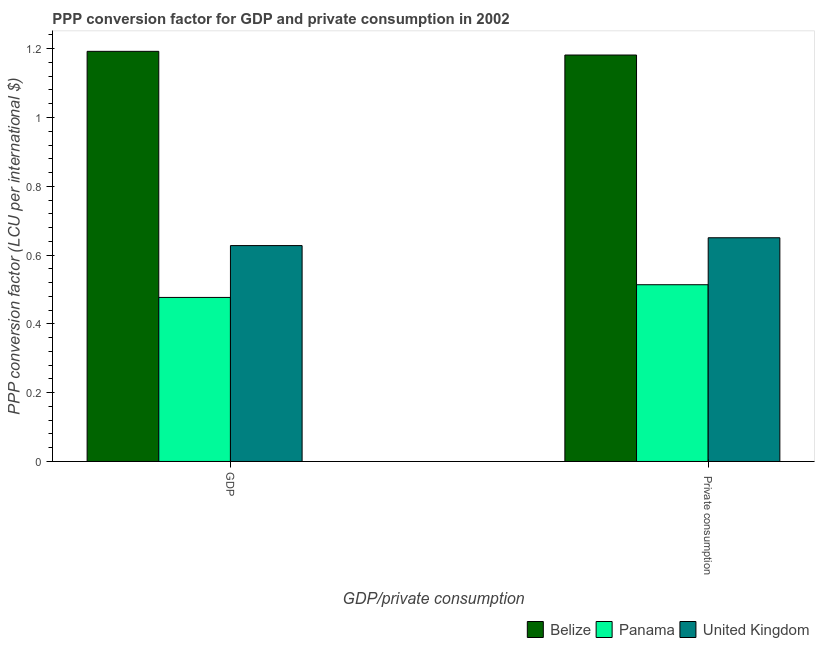How many groups of bars are there?
Your answer should be compact. 2. How many bars are there on the 1st tick from the left?
Your response must be concise. 3. What is the label of the 2nd group of bars from the left?
Make the answer very short.  Private consumption. What is the ppp conversion factor for gdp in United Kingdom?
Provide a succinct answer. 0.63. Across all countries, what is the maximum ppp conversion factor for private consumption?
Your response must be concise. 1.18. Across all countries, what is the minimum ppp conversion factor for private consumption?
Offer a terse response. 0.51. In which country was the ppp conversion factor for gdp maximum?
Keep it short and to the point. Belize. In which country was the ppp conversion factor for private consumption minimum?
Your answer should be very brief. Panama. What is the total ppp conversion factor for gdp in the graph?
Make the answer very short. 2.3. What is the difference between the ppp conversion factor for gdp in United Kingdom and that in Belize?
Ensure brevity in your answer.  -0.56. What is the difference between the ppp conversion factor for private consumption in United Kingdom and the ppp conversion factor for gdp in Panama?
Provide a succinct answer. 0.17. What is the average ppp conversion factor for gdp per country?
Your response must be concise. 0.77. What is the difference between the ppp conversion factor for gdp and ppp conversion factor for private consumption in United Kingdom?
Offer a very short reply. -0.02. What is the ratio of the ppp conversion factor for gdp in United Kingdom to that in Panama?
Give a very brief answer. 1.32. What does the 1st bar from the left in GDP represents?
Provide a short and direct response. Belize. What does the 3rd bar from the right in  Private consumption represents?
Your response must be concise. Belize. How many bars are there?
Offer a very short reply. 6. How many countries are there in the graph?
Provide a succinct answer. 3. What is the difference between two consecutive major ticks on the Y-axis?
Provide a short and direct response. 0.2. Are the values on the major ticks of Y-axis written in scientific E-notation?
Offer a very short reply. No. How many legend labels are there?
Provide a short and direct response. 3. How are the legend labels stacked?
Give a very brief answer. Horizontal. What is the title of the graph?
Offer a terse response. PPP conversion factor for GDP and private consumption in 2002. Does "Zambia" appear as one of the legend labels in the graph?
Your response must be concise. No. What is the label or title of the X-axis?
Your answer should be very brief. GDP/private consumption. What is the label or title of the Y-axis?
Keep it short and to the point. PPP conversion factor (LCU per international $). What is the PPP conversion factor (LCU per international $) of Belize in GDP?
Provide a short and direct response. 1.19. What is the PPP conversion factor (LCU per international $) of Panama in GDP?
Your answer should be very brief. 0.48. What is the PPP conversion factor (LCU per international $) of United Kingdom in GDP?
Your response must be concise. 0.63. What is the PPP conversion factor (LCU per international $) in Belize in  Private consumption?
Offer a terse response. 1.18. What is the PPP conversion factor (LCU per international $) in Panama in  Private consumption?
Provide a short and direct response. 0.51. What is the PPP conversion factor (LCU per international $) in United Kingdom in  Private consumption?
Provide a short and direct response. 0.65. Across all GDP/private consumption, what is the maximum PPP conversion factor (LCU per international $) of Belize?
Your response must be concise. 1.19. Across all GDP/private consumption, what is the maximum PPP conversion factor (LCU per international $) of Panama?
Your answer should be compact. 0.51. Across all GDP/private consumption, what is the maximum PPP conversion factor (LCU per international $) in United Kingdom?
Offer a very short reply. 0.65. Across all GDP/private consumption, what is the minimum PPP conversion factor (LCU per international $) in Belize?
Offer a very short reply. 1.18. Across all GDP/private consumption, what is the minimum PPP conversion factor (LCU per international $) of Panama?
Give a very brief answer. 0.48. Across all GDP/private consumption, what is the minimum PPP conversion factor (LCU per international $) in United Kingdom?
Keep it short and to the point. 0.63. What is the total PPP conversion factor (LCU per international $) in Belize in the graph?
Ensure brevity in your answer.  2.37. What is the total PPP conversion factor (LCU per international $) of Panama in the graph?
Your answer should be compact. 0.99. What is the total PPP conversion factor (LCU per international $) in United Kingdom in the graph?
Your answer should be very brief. 1.28. What is the difference between the PPP conversion factor (LCU per international $) of Belize in GDP and that in  Private consumption?
Give a very brief answer. 0.01. What is the difference between the PPP conversion factor (LCU per international $) of Panama in GDP and that in  Private consumption?
Your answer should be compact. -0.04. What is the difference between the PPP conversion factor (LCU per international $) of United Kingdom in GDP and that in  Private consumption?
Your response must be concise. -0.02. What is the difference between the PPP conversion factor (LCU per international $) in Belize in GDP and the PPP conversion factor (LCU per international $) in Panama in  Private consumption?
Provide a succinct answer. 0.68. What is the difference between the PPP conversion factor (LCU per international $) in Belize in GDP and the PPP conversion factor (LCU per international $) in United Kingdom in  Private consumption?
Offer a very short reply. 0.54. What is the difference between the PPP conversion factor (LCU per international $) of Panama in GDP and the PPP conversion factor (LCU per international $) of United Kingdom in  Private consumption?
Provide a succinct answer. -0.17. What is the average PPP conversion factor (LCU per international $) of Belize per GDP/private consumption?
Your response must be concise. 1.19. What is the average PPP conversion factor (LCU per international $) in Panama per GDP/private consumption?
Keep it short and to the point. 0.5. What is the average PPP conversion factor (LCU per international $) in United Kingdom per GDP/private consumption?
Make the answer very short. 0.64. What is the difference between the PPP conversion factor (LCU per international $) in Belize and PPP conversion factor (LCU per international $) in Panama in GDP?
Provide a short and direct response. 0.72. What is the difference between the PPP conversion factor (LCU per international $) in Belize and PPP conversion factor (LCU per international $) in United Kingdom in GDP?
Your response must be concise. 0.56. What is the difference between the PPP conversion factor (LCU per international $) in Panama and PPP conversion factor (LCU per international $) in United Kingdom in GDP?
Give a very brief answer. -0.15. What is the difference between the PPP conversion factor (LCU per international $) in Belize and PPP conversion factor (LCU per international $) in Panama in  Private consumption?
Give a very brief answer. 0.67. What is the difference between the PPP conversion factor (LCU per international $) in Belize and PPP conversion factor (LCU per international $) in United Kingdom in  Private consumption?
Ensure brevity in your answer.  0.53. What is the difference between the PPP conversion factor (LCU per international $) of Panama and PPP conversion factor (LCU per international $) of United Kingdom in  Private consumption?
Offer a terse response. -0.14. What is the ratio of the PPP conversion factor (LCU per international $) in Belize in GDP to that in  Private consumption?
Your answer should be very brief. 1.01. What is the ratio of the PPP conversion factor (LCU per international $) of Panama in GDP to that in  Private consumption?
Your response must be concise. 0.93. What is the difference between the highest and the second highest PPP conversion factor (LCU per international $) of Belize?
Your answer should be compact. 0.01. What is the difference between the highest and the second highest PPP conversion factor (LCU per international $) of Panama?
Keep it short and to the point. 0.04. What is the difference between the highest and the second highest PPP conversion factor (LCU per international $) in United Kingdom?
Ensure brevity in your answer.  0.02. What is the difference between the highest and the lowest PPP conversion factor (LCU per international $) in Belize?
Keep it short and to the point. 0.01. What is the difference between the highest and the lowest PPP conversion factor (LCU per international $) in Panama?
Provide a short and direct response. 0.04. What is the difference between the highest and the lowest PPP conversion factor (LCU per international $) in United Kingdom?
Offer a very short reply. 0.02. 